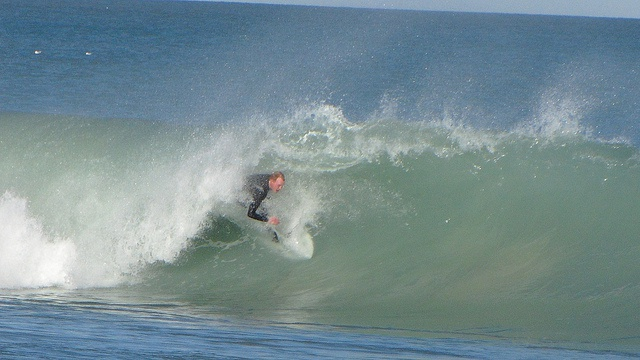Describe the objects in this image and their specific colors. I can see surfboard in gray, darkgray, and lightgray tones and people in gray, darkgray, and black tones in this image. 